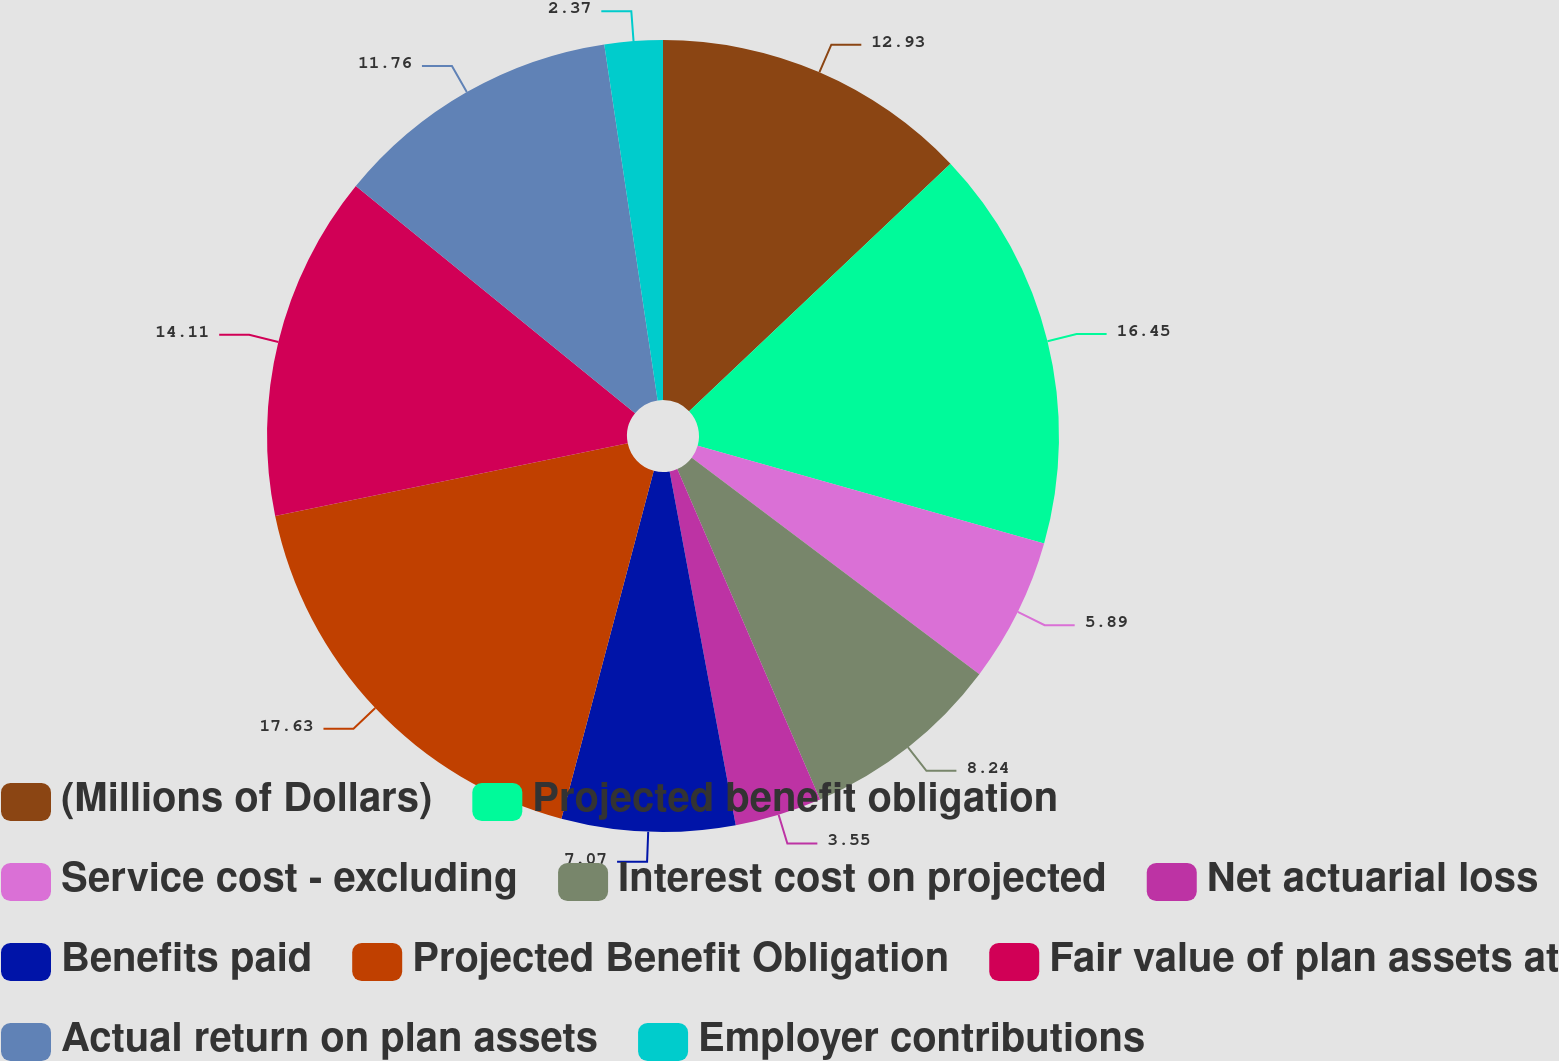Convert chart to OTSL. <chart><loc_0><loc_0><loc_500><loc_500><pie_chart><fcel>(Millions of Dollars)<fcel>Projected benefit obligation<fcel>Service cost - excluding<fcel>Interest cost on projected<fcel>Net actuarial loss<fcel>Benefits paid<fcel>Projected Benefit Obligation<fcel>Fair value of plan assets at<fcel>Actual return on plan assets<fcel>Employer contributions<nl><fcel>12.93%<fcel>16.45%<fcel>5.89%<fcel>8.24%<fcel>3.55%<fcel>7.07%<fcel>17.63%<fcel>14.11%<fcel>11.76%<fcel>2.37%<nl></chart> 